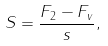<formula> <loc_0><loc_0><loc_500><loc_500>S = \frac { F _ { 2 } - F _ { v } } { s } ,</formula> 